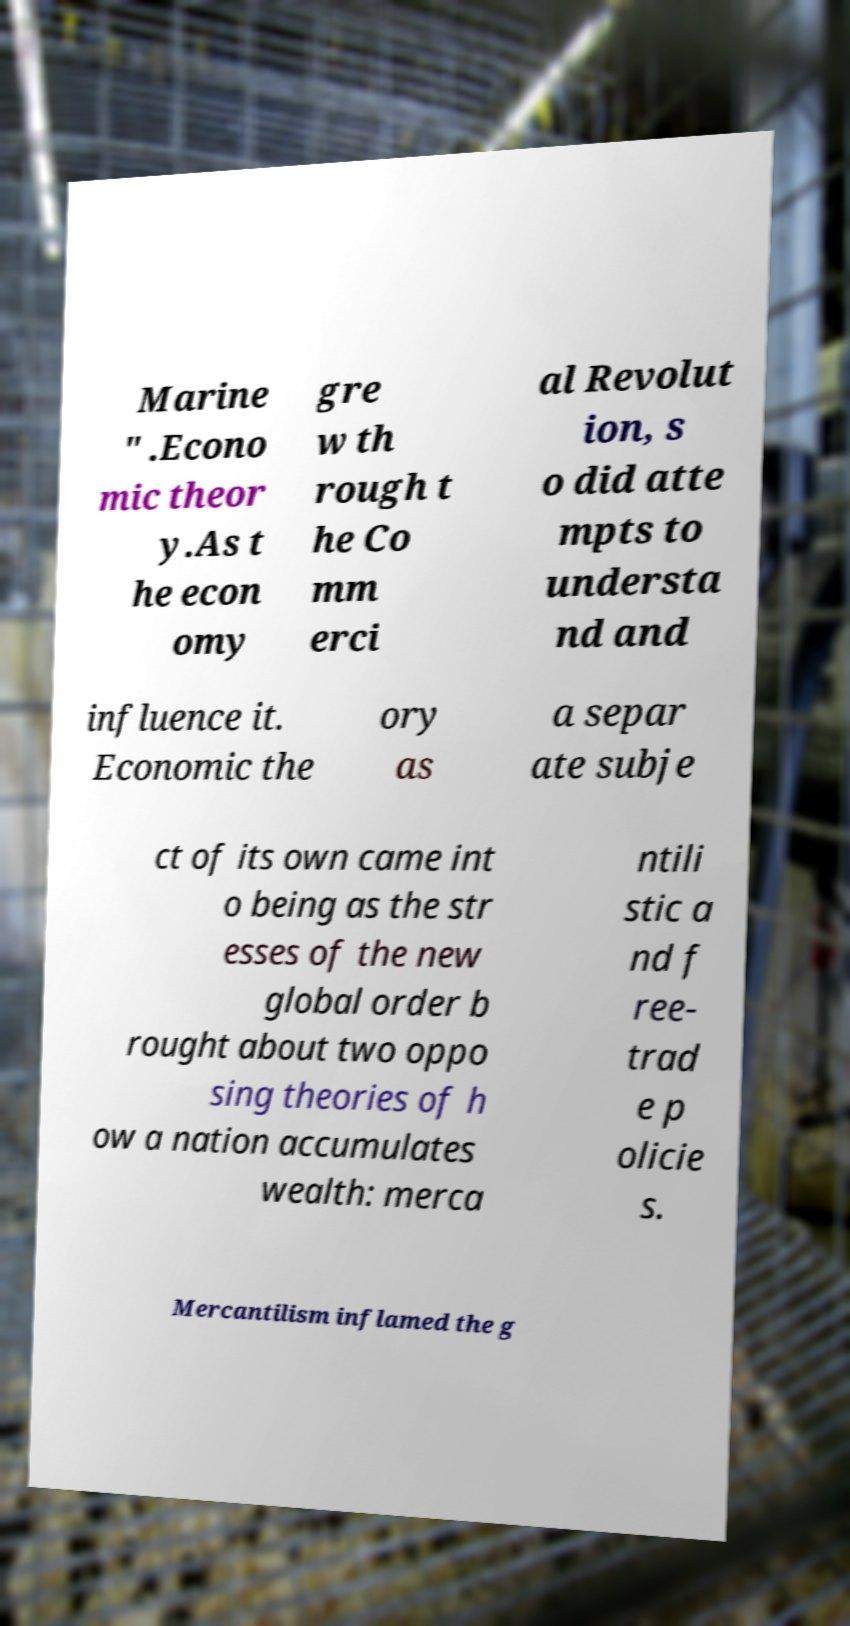Please read and relay the text visible in this image. What does it say? Marine " .Econo mic theor y.As t he econ omy gre w th rough t he Co mm erci al Revolut ion, s o did atte mpts to understa nd and influence it. Economic the ory as a separ ate subje ct of its own came int o being as the str esses of the new global order b rought about two oppo sing theories of h ow a nation accumulates wealth: merca ntili stic a nd f ree- trad e p olicie s. Mercantilism inflamed the g 